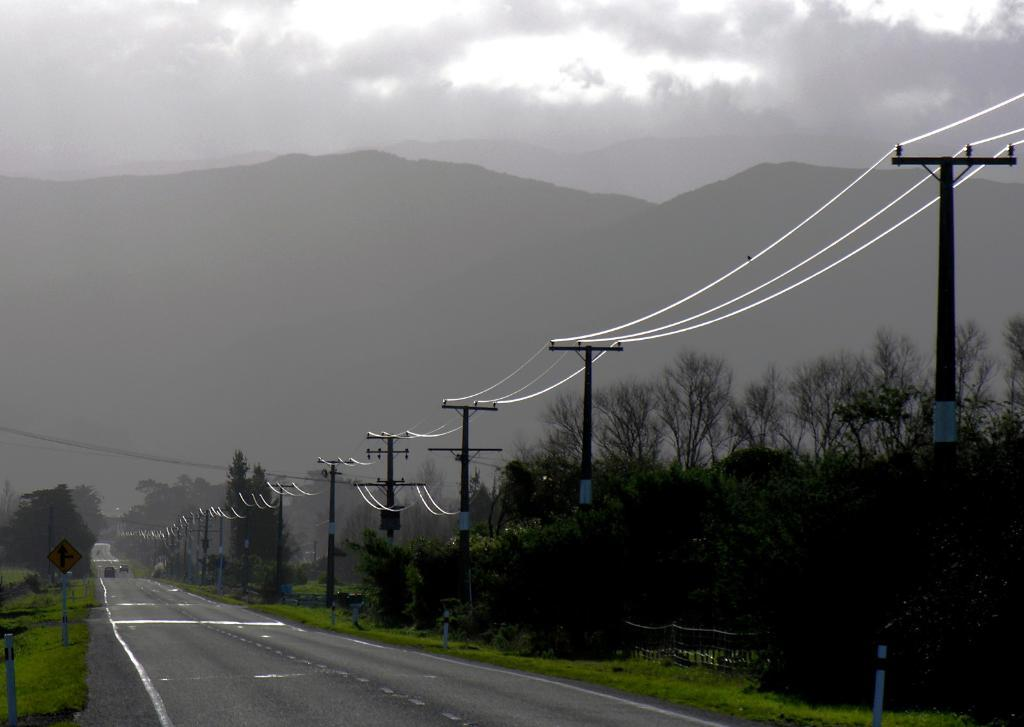What can be seen on the road in the image? There are vehicles on the road in the image. What is present near the road in the image? There is a fence in the image. What is located near the fence in the image? There is a sign board in the image. What else can be seen in the image besides the road, fence, and sign board? There are poles and wires in the image. What is visible in the background of the image? The sky, clouds, a mountain, trees, and grass are visible in the background of the image. Can you tell me what type of record is being played in the image? There is no record present in the image. Is there a girl holding a basket in the image? There is no girl or basket present in the image. 